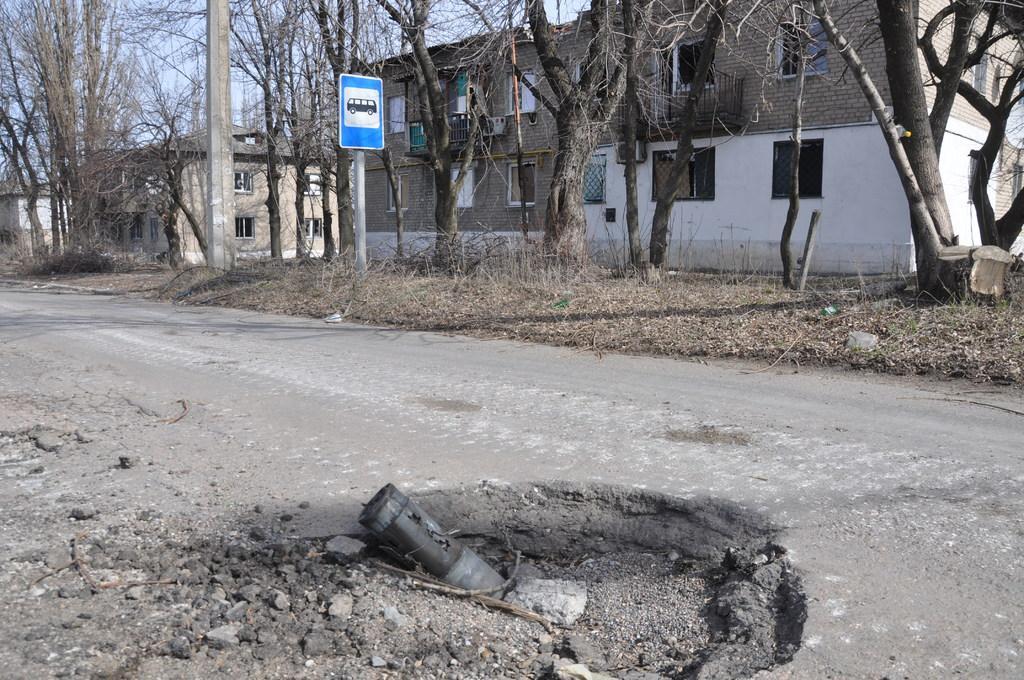Can you describe this image briefly? In this picture we can see many buildings and trees. At the bottom there is a steel pipe near to the road. In the center the bus sign board, beside that there is a concrete pole. At the top there is a sky. On the left we can see grass and plants. 